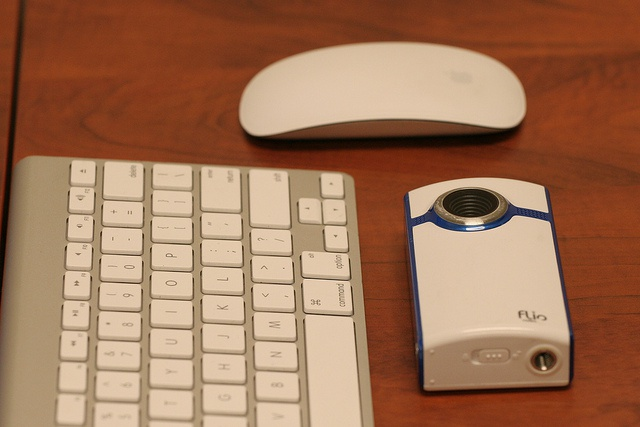Describe the objects in this image and their specific colors. I can see keyboard in maroon, tan, and gray tones and mouse in maroon and tan tones in this image. 